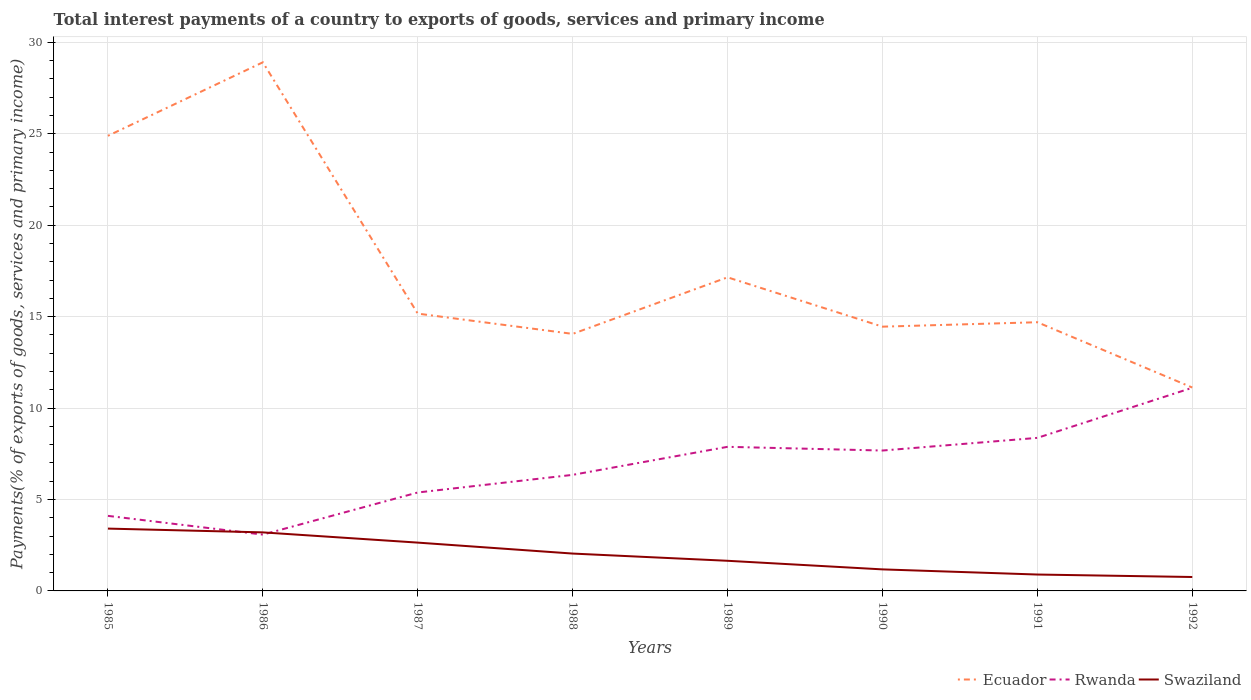Across all years, what is the maximum total interest payments in Swaziland?
Your response must be concise. 0.76. In which year was the total interest payments in Swaziland maximum?
Give a very brief answer. 1992. What is the total total interest payments in Swaziland in the graph?
Provide a succinct answer. 0.56. What is the difference between the highest and the second highest total interest payments in Rwanda?
Ensure brevity in your answer.  8.03. Is the total interest payments in Rwanda strictly greater than the total interest payments in Ecuador over the years?
Ensure brevity in your answer.  Yes. How many lines are there?
Provide a succinct answer. 3. How many years are there in the graph?
Your response must be concise. 8. Are the values on the major ticks of Y-axis written in scientific E-notation?
Make the answer very short. No. Does the graph contain any zero values?
Your answer should be compact. No. Does the graph contain grids?
Provide a short and direct response. Yes. Where does the legend appear in the graph?
Keep it short and to the point. Bottom right. How are the legend labels stacked?
Offer a very short reply. Horizontal. What is the title of the graph?
Give a very brief answer. Total interest payments of a country to exports of goods, services and primary income. Does "Hungary" appear as one of the legend labels in the graph?
Give a very brief answer. No. What is the label or title of the X-axis?
Provide a short and direct response. Years. What is the label or title of the Y-axis?
Offer a very short reply. Payments(% of exports of goods, services and primary income). What is the Payments(% of exports of goods, services and primary income) in Ecuador in 1985?
Provide a short and direct response. 24.89. What is the Payments(% of exports of goods, services and primary income) in Rwanda in 1985?
Your response must be concise. 4.11. What is the Payments(% of exports of goods, services and primary income) of Swaziland in 1985?
Your answer should be very brief. 3.41. What is the Payments(% of exports of goods, services and primary income) in Ecuador in 1986?
Your answer should be compact. 28.91. What is the Payments(% of exports of goods, services and primary income) of Rwanda in 1986?
Offer a very short reply. 3.08. What is the Payments(% of exports of goods, services and primary income) in Swaziland in 1986?
Make the answer very short. 3.2. What is the Payments(% of exports of goods, services and primary income) of Ecuador in 1987?
Your answer should be very brief. 15.17. What is the Payments(% of exports of goods, services and primary income) of Rwanda in 1987?
Ensure brevity in your answer.  5.38. What is the Payments(% of exports of goods, services and primary income) in Swaziland in 1987?
Give a very brief answer. 2.64. What is the Payments(% of exports of goods, services and primary income) of Ecuador in 1988?
Give a very brief answer. 14.06. What is the Payments(% of exports of goods, services and primary income) in Rwanda in 1988?
Offer a very short reply. 6.35. What is the Payments(% of exports of goods, services and primary income) in Swaziland in 1988?
Your response must be concise. 2.04. What is the Payments(% of exports of goods, services and primary income) of Ecuador in 1989?
Your answer should be very brief. 17.15. What is the Payments(% of exports of goods, services and primary income) in Rwanda in 1989?
Offer a very short reply. 7.88. What is the Payments(% of exports of goods, services and primary income) of Swaziland in 1989?
Provide a succinct answer. 1.65. What is the Payments(% of exports of goods, services and primary income) of Ecuador in 1990?
Your answer should be compact. 14.45. What is the Payments(% of exports of goods, services and primary income) of Rwanda in 1990?
Provide a short and direct response. 7.68. What is the Payments(% of exports of goods, services and primary income) in Swaziland in 1990?
Offer a terse response. 1.18. What is the Payments(% of exports of goods, services and primary income) of Ecuador in 1991?
Ensure brevity in your answer.  14.69. What is the Payments(% of exports of goods, services and primary income) in Rwanda in 1991?
Ensure brevity in your answer.  8.37. What is the Payments(% of exports of goods, services and primary income) of Swaziland in 1991?
Offer a very short reply. 0.9. What is the Payments(% of exports of goods, services and primary income) in Ecuador in 1992?
Give a very brief answer. 11.12. What is the Payments(% of exports of goods, services and primary income) of Rwanda in 1992?
Your answer should be very brief. 11.11. What is the Payments(% of exports of goods, services and primary income) of Swaziland in 1992?
Give a very brief answer. 0.76. Across all years, what is the maximum Payments(% of exports of goods, services and primary income) in Ecuador?
Make the answer very short. 28.91. Across all years, what is the maximum Payments(% of exports of goods, services and primary income) in Rwanda?
Give a very brief answer. 11.11. Across all years, what is the maximum Payments(% of exports of goods, services and primary income) in Swaziland?
Your answer should be very brief. 3.41. Across all years, what is the minimum Payments(% of exports of goods, services and primary income) of Ecuador?
Your answer should be compact. 11.12. Across all years, what is the minimum Payments(% of exports of goods, services and primary income) of Rwanda?
Your response must be concise. 3.08. Across all years, what is the minimum Payments(% of exports of goods, services and primary income) in Swaziland?
Make the answer very short. 0.76. What is the total Payments(% of exports of goods, services and primary income) in Ecuador in the graph?
Provide a short and direct response. 140.44. What is the total Payments(% of exports of goods, services and primary income) of Rwanda in the graph?
Offer a very short reply. 53.96. What is the total Payments(% of exports of goods, services and primary income) of Swaziland in the graph?
Offer a very short reply. 15.78. What is the difference between the Payments(% of exports of goods, services and primary income) in Ecuador in 1985 and that in 1986?
Make the answer very short. -4.02. What is the difference between the Payments(% of exports of goods, services and primary income) of Rwanda in 1985 and that in 1986?
Your response must be concise. 1.02. What is the difference between the Payments(% of exports of goods, services and primary income) in Swaziland in 1985 and that in 1986?
Provide a succinct answer. 0.21. What is the difference between the Payments(% of exports of goods, services and primary income) in Ecuador in 1985 and that in 1987?
Provide a short and direct response. 9.72. What is the difference between the Payments(% of exports of goods, services and primary income) of Rwanda in 1985 and that in 1987?
Your response must be concise. -1.28. What is the difference between the Payments(% of exports of goods, services and primary income) in Swaziland in 1985 and that in 1987?
Provide a short and direct response. 0.77. What is the difference between the Payments(% of exports of goods, services and primary income) of Ecuador in 1985 and that in 1988?
Give a very brief answer. 10.83. What is the difference between the Payments(% of exports of goods, services and primary income) in Rwanda in 1985 and that in 1988?
Offer a very short reply. -2.24. What is the difference between the Payments(% of exports of goods, services and primary income) in Swaziland in 1985 and that in 1988?
Make the answer very short. 1.37. What is the difference between the Payments(% of exports of goods, services and primary income) in Ecuador in 1985 and that in 1989?
Ensure brevity in your answer.  7.74. What is the difference between the Payments(% of exports of goods, services and primary income) in Rwanda in 1985 and that in 1989?
Provide a short and direct response. -3.78. What is the difference between the Payments(% of exports of goods, services and primary income) in Swaziland in 1985 and that in 1989?
Your answer should be very brief. 1.76. What is the difference between the Payments(% of exports of goods, services and primary income) of Ecuador in 1985 and that in 1990?
Ensure brevity in your answer.  10.44. What is the difference between the Payments(% of exports of goods, services and primary income) of Rwanda in 1985 and that in 1990?
Keep it short and to the point. -3.57. What is the difference between the Payments(% of exports of goods, services and primary income) in Swaziland in 1985 and that in 1990?
Ensure brevity in your answer.  2.23. What is the difference between the Payments(% of exports of goods, services and primary income) in Ecuador in 1985 and that in 1991?
Your response must be concise. 10.19. What is the difference between the Payments(% of exports of goods, services and primary income) of Rwanda in 1985 and that in 1991?
Offer a terse response. -4.27. What is the difference between the Payments(% of exports of goods, services and primary income) in Swaziland in 1985 and that in 1991?
Your answer should be very brief. 2.51. What is the difference between the Payments(% of exports of goods, services and primary income) in Ecuador in 1985 and that in 1992?
Make the answer very short. 13.77. What is the difference between the Payments(% of exports of goods, services and primary income) of Rwanda in 1985 and that in 1992?
Offer a very short reply. -7.01. What is the difference between the Payments(% of exports of goods, services and primary income) of Swaziland in 1985 and that in 1992?
Provide a short and direct response. 2.65. What is the difference between the Payments(% of exports of goods, services and primary income) of Ecuador in 1986 and that in 1987?
Give a very brief answer. 13.74. What is the difference between the Payments(% of exports of goods, services and primary income) of Rwanda in 1986 and that in 1987?
Your response must be concise. -2.3. What is the difference between the Payments(% of exports of goods, services and primary income) of Swaziland in 1986 and that in 1987?
Make the answer very short. 0.56. What is the difference between the Payments(% of exports of goods, services and primary income) in Ecuador in 1986 and that in 1988?
Make the answer very short. 14.85. What is the difference between the Payments(% of exports of goods, services and primary income) in Rwanda in 1986 and that in 1988?
Provide a short and direct response. -3.27. What is the difference between the Payments(% of exports of goods, services and primary income) of Swaziland in 1986 and that in 1988?
Ensure brevity in your answer.  1.16. What is the difference between the Payments(% of exports of goods, services and primary income) of Ecuador in 1986 and that in 1989?
Give a very brief answer. 11.76. What is the difference between the Payments(% of exports of goods, services and primary income) in Rwanda in 1986 and that in 1989?
Make the answer very short. -4.8. What is the difference between the Payments(% of exports of goods, services and primary income) in Swaziland in 1986 and that in 1989?
Keep it short and to the point. 1.55. What is the difference between the Payments(% of exports of goods, services and primary income) in Ecuador in 1986 and that in 1990?
Offer a terse response. 14.46. What is the difference between the Payments(% of exports of goods, services and primary income) of Rwanda in 1986 and that in 1990?
Offer a very short reply. -4.6. What is the difference between the Payments(% of exports of goods, services and primary income) in Swaziland in 1986 and that in 1990?
Your answer should be compact. 2.02. What is the difference between the Payments(% of exports of goods, services and primary income) of Ecuador in 1986 and that in 1991?
Offer a very short reply. 14.22. What is the difference between the Payments(% of exports of goods, services and primary income) in Rwanda in 1986 and that in 1991?
Your answer should be very brief. -5.29. What is the difference between the Payments(% of exports of goods, services and primary income) of Swaziland in 1986 and that in 1991?
Offer a terse response. 2.31. What is the difference between the Payments(% of exports of goods, services and primary income) in Ecuador in 1986 and that in 1992?
Offer a very short reply. 17.79. What is the difference between the Payments(% of exports of goods, services and primary income) of Rwanda in 1986 and that in 1992?
Offer a terse response. -8.03. What is the difference between the Payments(% of exports of goods, services and primary income) of Swaziland in 1986 and that in 1992?
Make the answer very short. 2.44. What is the difference between the Payments(% of exports of goods, services and primary income) of Ecuador in 1987 and that in 1988?
Provide a short and direct response. 1.11. What is the difference between the Payments(% of exports of goods, services and primary income) of Rwanda in 1987 and that in 1988?
Offer a terse response. -0.96. What is the difference between the Payments(% of exports of goods, services and primary income) in Swaziland in 1987 and that in 1988?
Offer a terse response. 0.6. What is the difference between the Payments(% of exports of goods, services and primary income) in Ecuador in 1987 and that in 1989?
Provide a succinct answer. -1.98. What is the difference between the Payments(% of exports of goods, services and primary income) of Rwanda in 1987 and that in 1989?
Make the answer very short. -2.5. What is the difference between the Payments(% of exports of goods, services and primary income) of Swaziland in 1987 and that in 1989?
Provide a succinct answer. 0.99. What is the difference between the Payments(% of exports of goods, services and primary income) of Ecuador in 1987 and that in 1990?
Provide a succinct answer. 0.71. What is the difference between the Payments(% of exports of goods, services and primary income) in Rwanda in 1987 and that in 1990?
Your answer should be compact. -2.29. What is the difference between the Payments(% of exports of goods, services and primary income) of Swaziland in 1987 and that in 1990?
Your response must be concise. 1.46. What is the difference between the Payments(% of exports of goods, services and primary income) of Ecuador in 1987 and that in 1991?
Ensure brevity in your answer.  0.47. What is the difference between the Payments(% of exports of goods, services and primary income) in Rwanda in 1987 and that in 1991?
Your answer should be compact. -2.99. What is the difference between the Payments(% of exports of goods, services and primary income) in Swaziland in 1987 and that in 1991?
Offer a very short reply. 1.75. What is the difference between the Payments(% of exports of goods, services and primary income) of Ecuador in 1987 and that in 1992?
Give a very brief answer. 4.04. What is the difference between the Payments(% of exports of goods, services and primary income) of Rwanda in 1987 and that in 1992?
Keep it short and to the point. -5.73. What is the difference between the Payments(% of exports of goods, services and primary income) of Swaziland in 1987 and that in 1992?
Give a very brief answer. 1.88. What is the difference between the Payments(% of exports of goods, services and primary income) in Ecuador in 1988 and that in 1989?
Your response must be concise. -3.09. What is the difference between the Payments(% of exports of goods, services and primary income) in Rwanda in 1988 and that in 1989?
Keep it short and to the point. -1.53. What is the difference between the Payments(% of exports of goods, services and primary income) of Swaziland in 1988 and that in 1989?
Offer a very short reply. 0.4. What is the difference between the Payments(% of exports of goods, services and primary income) in Ecuador in 1988 and that in 1990?
Ensure brevity in your answer.  -0.39. What is the difference between the Payments(% of exports of goods, services and primary income) in Rwanda in 1988 and that in 1990?
Give a very brief answer. -1.33. What is the difference between the Payments(% of exports of goods, services and primary income) of Swaziland in 1988 and that in 1990?
Offer a very short reply. 0.87. What is the difference between the Payments(% of exports of goods, services and primary income) in Ecuador in 1988 and that in 1991?
Offer a very short reply. -0.64. What is the difference between the Payments(% of exports of goods, services and primary income) of Rwanda in 1988 and that in 1991?
Your answer should be compact. -2.02. What is the difference between the Payments(% of exports of goods, services and primary income) of Swaziland in 1988 and that in 1991?
Ensure brevity in your answer.  1.15. What is the difference between the Payments(% of exports of goods, services and primary income) in Ecuador in 1988 and that in 1992?
Make the answer very short. 2.93. What is the difference between the Payments(% of exports of goods, services and primary income) in Rwanda in 1988 and that in 1992?
Offer a terse response. -4.76. What is the difference between the Payments(% of exports of goods, services and primary income) in Swaziland in 1988 and that in 1992?
Your answer should be compact. 1.28. What is the difference between the Payments(% of exports of goods, services and primary income) of Ecuador in 1989 and that in 1990?
Make the answer very short. 2.7. What is the difference between the Payments(% of exports of goods, services and primary income) of Rwanda in 1989 and that in 1990?
Offer a terse response. 0.2. What is the difference between the Payments(% of exports of goods, services and primary income) of Swaziland in 1989 and that in 1990?
Your answer should be compact. 0.47. What is the difference between the Payments(% of exports of goods, services and primary income) in Ecuador in 1989 and that in 1991?
Offer a very short reply. 2.46. What is the difference between the Payments(% of exports of goods, services and primary income) in Rwanda in 1989 and that in 1991?
Make the answer very short. -0.49. What is the difference between the Payments(% of exports of goods, services and primary income) in Swaziland in 1989 and that in 1991?
Provide a short and direct response. 0.75. What is the difference between the Payments(% of exports of goods, services and primary income) of Ecuador in 1989 and that in 1992?
Keep it short and to the point. 6.03. What is the difference between the Payments(% of exports of goods, services and primary income) of Rwanda in 1989 and that in 1992?
Give a very brief answer. -3.23. What is the difference between the Payments(% of exports of goods, services and primary income) in Swaziland in 1989 and that in 1992?
Your answer should be compact. 0.89. What is the difference between the Payments(% of exports of goods, services and primary income) in Ecuador in 1990 and that in 1991?
Your answer should be compact. -0.24. What is the difference between the Payments(% of exports of goods, services and primary income) of Rwanda in 1990 and that in 1991?
Provide a short and direct response. -0.69. What is the difference between the Payments(% of exports of goods, services and primary income) of Swaziland in 1990 and that in 1991?
Ensure brevity in your answer.  0.28. What is the difference between the Payments(% of exports of goods, services and primary income) in Ecuador in 1990 and that in 1992?
Offer a terse response. 3.33. What is the difference between the Payments(% of exports of goods, services and primary income) in Rwanda in 1990 and that in 1992?
Keep it short and to the point. -3.43. What is the difference between the Payments(% of exports of goods, services and primary income) in Swaziland in 1990 and that in 1992?
Make the answer very short. 0.42. What is the difference between the Payments(% of exports of goods, services and primary income) of Ecuador in 1991 and that in 1992?
Your answer should be very brief. 3.57. What is the difference between the Payments(% of exports of goods, services and primary income) in Rwanda in 1991 and that in 1992?
Your answer should be very brief. -2.74. What is the difference between the Payments(% of exports of goods, services and primary income) in Swaziland in 1991 and that in 1992?
Your answer should be very brief. 0.13. What is the difference between the Payments(% of exports of goods, services and primary income) in Ecuador in 1985 and the Payments(% of exports of goods, services and primary income) in Rwanda in 1986?
Offer a very short reply. 21.81. What is the difference between the Payments(% of exports of goods, services and primary income) in Ecuador in 1985 and the Payments(% of exports of goods, services and primary income) in Swaziland in 1986?
Provide a short and direct response. 21.69. What is the difference between the Payments(% of exports of goods, services and primary income) in Rwanda in 1985 and the Payments(% of exports of goods, services and primary income) in Swaziland in 1986?
Provide a short and direct response. 0.9. What is the difference between the Payments(% of exports of goods, services and primary income) in Ecuador in 1985 and the Payments(% of exports of goods, services and primary income) in Rwanda in 1987?
Provide a succinct answer. 19.51. What is the difference between the Payments(% of exports of goods, services and primary income) in Ecuador in 1985 and the Payments(% of exports of goods, services and primary income) in Swaziland in 1987?
Make the answer very short. 22.25. What is the difference between the Payments(% of exports of goods, services and primary income) of Rwanda in 1985 and the Payments(% of exports of goods, services and primary income) of Swaziland in 1987?
Offer a very short reply. 1.46. What is the difference between the Payments(% of exports of goods, services and primary income) of Ecuador in 1985 and the Payments(% of exports of goods, services and primary income) of Rwanda in 1988?
Offer a terse response. 18.54. What is the difference between the Payments(% of exports of goods, services and primary income) in Ecuador in 1985 and the Payments(% of exports of goods, services and primary income) in Swaziland in 1988?
Offer a terse response. 22.85. What is the difference between the Payments(% of exports of goods, services and primary income) in Rwanda in 1985 and the Payments(% of exports of goods, services and primary income) in Swaziland in 1988?
Ensure brevity in your answer.  2.06. What is the difference between the Payments(% of exports of goods, services and primary income) in Ecuador in 1985 and the Payments(% of exports of goods, services and primary income) in Rwanda in 1989?
Provide a succinct answer. 17.01. What is the difference between the Payments(% of exports of goods, services and primary income) of Ecuador in 1985 and the Payments(% of exports of goods, services and primary income) of Swaziland in 1989?
Keep it short and to the point. 23.24. What is the difference between the Payments(% of exports of goods, services and primary income) of Rwanda in 1985 and the Payments(% of exports of goods, services and primary income) of Swaziland in 1989?
Keep it short and to the point. 2.46. What is the difference between the Payments(% of exports of goods, services and primary income) in Ecuador in 1985 and the Payments(% of exports of goods, services and primary income) in Rwanda in 1990?
Ensure brevity in your answer.  17.21. What is the difference between the Payments(% of exports of goods, services and primary income) of Ecuador in 1985 and the Payments(% of exports of goods, services and primary income) of Swaziland in 1990?
Provide a succinct answer. 23.71. What is the difference between the Payments(% of exports of goods, services and primary income) in Rwanda in 1985 and the Payments(% of exports of goods, services and primary income) in Swaziland in 1990?
Your answer should be very brief. 2.93. What is the difference between the Payments(% of exports of goods, services and primary income) in Ecuador in 1985 and the Payments(% of exports of goods, services and primary income) in Rwanda in 1991?
Provide a succinct answer. 16.52. What is the difference between the Payments(% of exports of goods, services and primary income) of Ecuador in 1985 and the Payments(% of exports of goods, services and primary income) of Swaziland in 1991?
Offer a very short reply. 23.99. What is the difference between the Payments(% of exports of goods, services and primary income) of Rwanda in 1985 and the Payments(% of exports of goods, services and primary income) of Swaziland in 1991?
Offer a very short reply. 3.21. What is the difference between the Payments(% of exports of goods, services and primary income) in Ecuador in 1985 and the Payments(% of exports of goods, services and primary income) in Rwanda in 1992?
Your answer should be very brief. 13.78. What is the difference between the Payments(% of exports of goods, services and primary income) of Ecuador in 1985 and the Payments(% of exports of goods, services and primary income) of Swaziland in 1992?
Offer a very short reply. 24.13. What is the difference between the Payments(% of exports of goods, services and primary income) of Rwanda in 1985 and the Payments(% of exports of goods, services and primary income) of Swaziland in 1992?
Give a very brief answer. 3.34. What is the difference between the Payments(% of exports of goods, services and primary income) in Ecuador in 1986 and the Payments(% of exports of goods, services and primary income) in Rwanda in 1987?
Provide a succinct answer. 23.53. What is the difference between the Payments(% of exports of goods, services and primary income) in Ecuador in 1986 and the Payments(% of exports of goods, services and primary income) in Swaziland in 1987?
Make the answer very short. 26.27. What is the difference between the Payments(% of exports of goods, services and primary income) of Rwanda in 1986 and the Payments(% of exports of goods, services and primary income) of Swaziland in 1987?
Keep it short and to the point. 0.44. What is the difference between the Payments(% of exports of goods, services and primary income) in Ecuador in 1986 and the Payments(% of exports of goods, services and primary income) in Rwanda in 1988?
Provide a succinct answer. 22.56. What is the difference between the Payments(% of exports of goods, services and primary income) of Ecuador in 1986 and the Payments(% of exports of goods, services and primary income) of Swaziland in 1988?
Provide a short and direct response. 26.87. What is the difference between the Payments(% of exports of goods, services and primary income) in Rwanda in 1986 and the Payments(% of exports of goods, services and primary income) in Swaziland in 1988?
Ensure brevity in your answer.  1.04. What is the difference between the Payments(% of exports of goods, services and primary income) of Ecuador in 1986 and the Payments(% of exports of goods, services and primary income) of Rwanda in 1989?
Give a very brief answer. 21.03. What is the difference between the Payments(% of exports of goods, services and primary income) of Ecuador in 1986 and the Payments(% of exports of goods, services and primary income) of Swaziland in 1989?
Provide a succinct answer. 27.26. What is the difference between the Payments(% of exports of goods, services and primary income) in Rwanda in 1986 and the Payments(% of exports of goods, services and primary income) in Swaziland in 1989?
Offer a very short reply. 1.43. What is the difference between the Payments(% of exports of goods, services and primary income) in Ecuador in 1986 and the Payments(% of exports of goods, services and primary income) in Rwanda in 1990?
Your answer should be very brief. 21.23. What is the difference between the Payments(% of exports of goods, services and primary income) in Ecuador in 1986 and the Payments(% of exports of goods, services and primary income) in Swaziland in 1990?
Make the answer very short. 27.73. What is the difference between the Payments(% of exports of goods, services and primary income) of Rwanda in 1986 and the Payments(% of exports of goods, services and primary income) of Swaziland in 1990?
Offer a very short reply. 1.9. What is the difference between the Payments(% of exports of goods, services and primary income) of Ecuador in 1986 and the Payments(% of exports of goods, services and primary income) of Rwanda in 1991?
Ensure brevity in your answer.  20.54. What is the difference between the Payments(% of exports of goods, services and primary income) of Ecuador in 1986 and the Payments(% of exports of goods, services and primary income) of Swaziland in 1991?
Offer a very short reply. 28.01. What is the difference between the Payments(% of exports of goods, services and primary income) in Rwanda in 1986 and the Payments(% of exports of goods, services and primary income) in Swaziland in 1991?
Your answer should be very brief. 2.18. What is the difference between the Payments(% of exports of goods, services and primary income) of Ecuador in 1986 and the Payments(% of exports of goods, services and primary income) of Rwanda in 1992?
Offer a very short reply. 17.8. What is the difference between the Payments(% of exports of goods, services and primary income) in Ecuador in 1986 and the Payments(% of exports of goods, services and primary income) in Swaziland in 1992?
Keep it short and to the point. 28.15. What is the difference between the Payments(% of exports of goods, services and primary income) in Rwanda in 1986 and the Payments(% of exports of goods, services and primary income) in Swaziland in 1992?
Provide a short and direct response. 2.32. What is the difference between the Payments(% of exports of goods, services and primary income) of Ecuador in 1987 and the Payments(% of exports of goods, services and primary income) of Rwanda in 1988?
Offer a terse response. 8.82. What is the difference between the Payments(% of exports of goods, services and primary income) of Ecuador in 1987 and the Payments(% of exports of goods, services and primary income) of Swaziland in 1988?
Offer a terse response. 13.12. What is the difference between the Payments(% of exports of goods, services and primary income) of Rwanda in 1987 and the Payments(% of exports of goods, services and primary income) of Swaziland in 1988?
Provide a succinct answer. 3.34. What is the difference between the Payments(% of exports of goods, services and primary income) in Ecuador in 1987 and the Payments(% of exports of goods, services and primary income) in Rwanda in 1989?
Ensure brevity in your answer.  7.29. What is the difference between the Payments(% of exports of goods, services and primary income) of Ecuador in 1987 and the Payments(% of exports of goods, services and primary income) of Swaziland in 1989?
Provide a succinct answer. 13.52. What is the difference between the Payments(% of exports of goods, services and primary income) in Rwanda in 1987 and the Payments(% of exports of goods, services and primary income) in Swaziland in 1989?
Your answer should be compact. 3.74. What is the difference between the Payments(% of exports of goods, services and primary income) in Ecuador in 1987 and the Payments(% of exports of goods, services and primary income) in Rwanda in 1990?
Your response must be concise. 7.49. What is the difference between the Payments(% of exports of goods, services and primary income) in Ecuador in 1987 and the Payments(% of exports of goods, services and primary income) in Swaziland in 1990?
Provide a succinct answer. 13.99. What is the difference between the Payments(% of exports of goods, services and primary income) in Rwanda in 1987 and the Payments(% of exports of goods, services and primary income) in Swaziland in 1990?
Make the answer very short. 4.21. What is the difference between the Payments(% of exports of goods, services and primary income) of Ecuador in 1987 and the Payments(% of exports of goods, services and primary income) of Rwanda in 1991?
Your answer should be compact. 6.8. What is the difference between the Payments(% of exports of goods, services and primary income) of Ecuador in 1987 and the Payments(% of exports of goods, services and primary income) of Swaziland in 1991?
Your answer should be very brief. 14.27. What is the difference between the Payments(% of exports of goods, services and primary income) of Rwanda in 1987 and the Payments(% of exports of goods, services and primary income) of Swaziland in 1991?
Your response must be concise. 4.49. What is the difference between the Payments(% of exports of goods, services and primary income) of Ecuador in 1987 and the Payments(% of exports of goods, services and primary income) of Rwanda in 1992?
Your answer should be very brief. 4.06. What is the difference between the Payments(% of exports of goods, services and primary income) of Ecuador in 1987 and the Payments(% of exports of goods, services and primary income) of Swaziland in 1992?
Offer a terse response. 14.4. What is the difference between the Payments(% of exports of goods, services and primary income) of Rwanda in 1987 and the Payments(% of exports of goods, services and primary income) of Swaziland in 1992?
Keep it short and to the point. 4.62. What is the difference between the Payments(% of exports of goods, services and primary income) of Ecuador in 1988 and the Payments(% of exports of goods, services and primary income) of Rwanda in 1989?
Your response must be concise. 6.18. What is the difference between the Payments(% of exports of goods, services and primary income) in Ecuador in 1988 and the Payments(% of exports of goods, services and primary income) in Swaziland in 1989?
Make the answer very short. 12.41. What is the difference between the Payments(% of exports of goods, services and primary income) of Rwanda in 1988 and the Payments(% of exports of goods, services and primary income) of Swaziland in 1989?
Your response must be concise. 4.7. What is the difference between the Payments(% of exports of goods, services and primary income) of Ecuador in 1988 and the Payments(% of exports of goods, services and primary income) of Rwanda in 1990?
Ensure brevity in your answer.  6.38. What is the difference between the Payments(% of exports of goods, services and primary income) of Ecuador in 1988 and the Payments(% of exports of goods, services and primary income) of Swaziland in 1990?
Your answer should be compact. 12.88. What is the difference between the Payments(% of exports of goods, services and primary income) in Rwanda in 1988 and the Payments(% of exports of goods, services and primary income) in Swaziland in 1990?
Make the answer very short. 5.17. What is the difference between the Payments(% of exports of goods, services and primary income) of Ecuador in 1988 and the Payments(% of exports of goods, services and primary income) of Rwanda in 1991?
Your response must be concise. 5.69. What is the difference between the Payments(% of exports of goods, services and primary income) in Ecuador in 1988 and the Payments(% of exports of goods, services and primary income) in Swaziland in 1991?
Offer a very short reply. 13.16. What is the difference between the Payments(% of exports of goods, services and primary income) in Rwanda in 1988 and the Payments(% of exports of goods, services and primary income) in Swaziland in 1991?
Your response must be concise. 5.45. What is the difference between the Payments(% of exports of goods, services and primary income) of Ecuador in 1988 and the Payments(% of exports of goods, services and primary income) of Rwanda in 1992?
Keep it short and to the point. 2.95. What is the difference between the Payments(% of exports of goods, services and primary income) in Ecuador in 1988 and the Payments(% of exports of goods, services and primary income) in Swaziland in 1992?
Provide a short and direct response. 13.3. What is the difference between the Payments(% of exports of goods, services and primary income) in Rwanda in 1988 and the Payments(% of exports of goods, services and primary income) in Swaziland in 1992?
Offer a very short reply. 5.59. What is the difference between the Payments(% of exports of goods, services and primary income) of Ecuador in 1989 and the Payments(% of exports of goods, services and primary income) of Rwanda in 1990?
Your answer should be very brief. 9.47. What is the difference between the Payments(% of exports of goods, services and primary income) of Ecuador in 1989 and the Payments(% of exports of goods, services and primary income) of Swaziland in 1990?
Your answer should be very brief. 15.97. What is the difference between the Payments(% of exports of goods, services and primary income) of Rwanda in 1989 and the Payments(% of exports of goods, services and primary income) of Swaziland in 1990?
Offer a terse response. 6.7. What is the difference between the Payments(% of exports of goods, services and primary income) in Ecuador in 1989 and the Payments(% of exports of goods, services and primary income) in Rwanda in 1991?
Keep it short and to the point. 8.78. What is the difference between the Payments(% of exports of goods, services and primary income) in Ecuador in 1989 and the Payments(% of exports of goods, services and primary income) in Swaziland in 1991?
Your answer should be very brief. 16.25. What is the difference between the Payments(% of exports of goods, services and primary income) of Rwanda in 1989 and the Payments(% of exports of goods, services and primary income) of Swaziland in 1991?
Offer a very short reply. 6.98. What is the difference between the Payments(% of exports of goods, services and primary income) in Ecuador in 1989 and the Payments(% of exports of goods, services and primary income) in Rwanda in 1992?
Your answer should be compact. 6.04. What is the difference between the Payments(% of exports of goods, services and primary income) of Ecuador in 1989 and the Payments(% of exports of goods, services and primary income) of Swaziland in 1992?
Provide a succinct answer. 16.39. What is the difference between the Payments(% of exports of goods, services and primary income) in Rwanda in 1989 and the Payments(% of exports of goods, services and primary income) in Swaziland in 1992?
Provide a short and direct response. 7.12. What is the difference between the Payments(% of exports of goods, services and primary income) of Ecuador in 1990 and the Payments(% of exports of goods, services and primary income) of Rwanda in 1991?
Your response must be concise. 6.08. What is the difference between the Payments(% of exports of goods, services and primary income) in Ecuador in 1990 and the Payments(% of exports of goods, services and primary income) in Swaziland in 1991?
Your answer should be very brief. 13.56. What is the difference between the Payments(% of exports of goods, services and primary income) of Rwanda in 1990 and the Payments(% of exports of goods, services and primary income) of Swaziland in 1991?
Offer a very short reply. 6.78. What is the difference between the Payments(% of exports of goods, services and primary income) of Ecuador in 1990 and the Payments(% of exports of goods, services and primary income) of Rwanda in 1992?
Provide a short and direct response. 3.34. What is the difference between the Payments(% of exports of goods, services and primary income) in Ecuador in 1990 and the Payments(% of exports of goods, services and primary income) in Swaziland in 1992?
Provide a short and direct response. 13.69. What is the difference between the Payments(% of exports of goods, services and primary income) in Rwanda in 1990 and the Payments(% of exports of goods, services and primary income) in Swaziland in 1992?
Provide a short and direct response. 6.92. What is the difference between the Payments(% of exports of goods, services and primary income) of Ecuador in 1991 and the Payments(% of exports of goods, services and primary income) of Rwanda in 1992?
Provide a succinct answer. 3.58. What is the difference between the Payments(% of exports of goods, services and primary income) of Ecuador in 1991 and the Payments(% of exports of goods, services and primary income) of Swaziland in 1992?
Make the answer very short. 13.93. What is the difference between the Payments(% of exports of goods, services and primary income) of Rwanda in 1991 and the Payments(% of exports of goods, services and primary income) of Swaziland in 1992?
Offer a very short reply. 7.61. What is the average Payments(% of exports of goods, services and primary income) in Ecuador per year?
Provide a short and direct response. 17.56. What is the average Payments(% of exports of goods, services and primary income) of Rwanda per year?
Offer a terse response. 6.74. What is the average Payments(% of exports of goods, services and primary income) of Swaziland per year?
Offer a terse response. 1.97. In the year 1985, what is the difference between the Payments(% of exports of goods, services and primary income) in Ecuador and Payments(% of exports of goods, services and primary income) in Rwanda?
Offer a terse response. 20.78. In the year 1985, what is the difference between the Payments(% of exports of goods, services and primary income) in Ecuador and Payments(% of exports of goods, services and primary income) in Swaziland?
Keep it short and to the point. 21.48. In the year 1985, what is the difference between the Payments(% of exports of goods, services and primary income) of Rwanda and Payments(% of exports of goods, services and primary income) of Swaziland?
Ensure brevity in your answer.  0.7. In the year 1986, what is the difference between the Payments(% of exports of goods, services and primary income) of Ecuador and Payments(% of exports of goods, services and primary income) of Rwanda?
Provide a short and direct response. 25.83. In the year 1986, what is the difference between the Payments(% of exports of goods, services and primary income) in Ecuador and Payments(% of exports of goods, services and primary income) in Swaziland?
Offer a very short reply. 25.71. In the year 1986, what is the difference between the Payments(% of exports of goods, services and primary income) of Rwanda and Payments(% of exports of goods, services and primary income) of Swaziland?
Give a very brief answer. -0.12. In the year 1987, what is the difference between the Payments(% of exports of goods, services and primary income) in Ecuador and Payments(% of exports of goods, services and primary income) in Rwanda?
Offer a terse response. 9.78. In the year 1987, what is the difference between the Payments(% of exports of goods, services and primary income) in Ecuador and Payments(% of exports of goods, services and primary income) in Swaziland?
Make the answer very short. 12.52. In the year 1987, what is the difference between the Payments(% of exports of goods, services and primary income) in Rwanda and Payments(% of exports of goods, services and primary income) in Swaziland?
Your answer should be very brief. 2.74. In the year 1988, what is the difference between the Payments(% of exports of goods, services and primary income) of Ecuador and Payments(% of exports of goods, services and primary income) of Rwanda?
Give a very brief answer. 7.71. In the year 1988, what is the difference between the Payments(% of exports of goods, services and primary income) of Ecuador and Payments(% of exports of goods, services and primary income) of Swaziland?
Your answer should be very brief. 12.01. In the year 1988, what is the difference between the Payments(% of exports of goods, services and primary income) of Rwanda and Payments(% of exports of goods, services and primary income) of Swaziland?
Make the answer very short. 4.3. In the year 1989, what is the difference between the Payments(% of exports of goods, services and primary income) of Ecuador and Payments(% of exports of goods, services and primary income) of Rwanda?
Offer a very short reply. 9.27. In the year 1989, what is the difference between the Payments(% of exports of goods, services and primary income) in Ecuador and Payments(% of exports of goods, services and primary income) in Swaziland?
Provide a short and direct response. 15.5. In the year 1989, what is the difference between the Payments(% of exports of goods, services and primary income) of Rwanda and Payments(% of exports of goods, services and primary income) of Swaziland?
Your response must be concise. 6.23. In the year 1990, what is the difference between the Payments(% of exports of goods, services and primary income) of Ecuador and Payments(% of exports of goods, services and primary income) of Rwanda?
Make the answer very short. 6.77. In the year 1990, what is the difference between the Payments(% of exports of goods, services and primary income) of Ecuador and Payments(% of exports of goods, services and primary income) of Swaziland?
Provide a succinct answer. 13.27. In the year 1990, what is the difference between the Payments(% of exports of goods, services and primary income) in Rwanda and Payments(% of exports of goods, services and primary income) in Swaziland?
Keep it short and to the point. 6.5. In the year 1991, what is the difference between the Payments(% of exports of goods, services and primary income) in Ecuador and Payments(% of exports of goods, services and primary income) in Rwanda?
Your answer should be very brief. 6.32. In the year 1991, what is the difference between the Payments(% of exports of goods, services and primary income) in Ecuador and Payments(% of exports of goods, services and primary income) in Swaziland?
Give a very brief answer. 13.8. In the year 1991, what is the difference between the Payments(% of exports of goods, services and primary income) in Rwanda and Payments(% of exports of goods, services and primary income) in Swaziland?
Keep it short and to the point. 7.47. In the year 1992, what is the difference between the Payments(% of exports of goods, services and primary income) of Ecuador and Payments(% of exports of goods, services and primary income) of Rwanda?
Ensure brevity in your answer.  0.01. In the year 1992, what is the difference between the Payments(% of exports of goods, services and primary income) of Ecuador and Payments(% of exports of goods, services and primary income) of Swaziland?
Ensure brevity in your answer.  10.36. In the year 1992, what is the difference between the Payments(% of exports of goods, services and primary income) of Rwanda and Payments(% of exports of goods, services and primary income) of Swaziland?
Your answer should be very brief. 10.35. What is the ratio of the Payments(% of exports of goods, services and primary income) of Ecuador in 1985 to that in 1986?
Provide a short and direct response. 0.86. What is the ratio of the Payments(% of exports of goods, services and primary income) of Rwanda in 1985 to that in 1986?
Your response must be concise. 1.33. What is the ratio of the Payments(% of exports of goods, services and primary income) of Swaziland in 1985 to that in 1986?
Keep it short and to the point. 1.06. What is the ratio of the Payments(% of exports of goods, services and primary income) of Ecuador in 1985 to that in 1987?
Make the answer very short. 1.64. What is the ratio of the Payments(% of exports of goods, services and primary income) in Rwanda in 1985 to that in 1987?
Provide a succinct answer. 0.76. What is the ratio of the Payments(% of exports of goods, services and primary income) in Swaziland in 1985 to that in 1987?
Ensure brevity in your answer.  1.29. What is the ratio of the Payments(% of exports of goods, services and primary income) in Ecuador in 1985 to that in 1988?
Offer a very short reply. 1.77. What is the ratio of the Payments(% of exports of goods, services and primary income) in Rwanda in 1985 to that in 1988?
Your response must be concise. 0.65. What is the ratio of the Payments(% of exports of goods, services and primary income) in Swaziland in 1985 to that in 1988?
Offer a very short reply. 1.67. What is the ratio of the Payments(% of exports of goods, services and primary income) in Ecuador in 1985 to that in 1989?
Your answer should be very brief. 1.45. What is the ratio of the Payments(% of exports of goods, services and primary income) of Rwanda in 1985 to that in 1989?
Keep it short and to the point. 0.52. What is the ratio of the Payments(% of exports of goods, services and primary income) in Swaziland in 1985 to that in 1989?
Your response must be concise. 2.07. What is the ratio of the Payments(% of exports of goods, services and primary income) in Ecuador in 1985 to that in 1990?
Your answer should be compact. 1.72. What is the ratio of the Payments(% of exports of goods, services and primary income) in Rwanda in 1985 to that in 1990?
Ensure brevity in your answer.  0.53. What is the ratio of the Payments(% of exports of goods, services and primary income) in Swaziland in 1985 to that in 1990?
Ensure brevity in your answer.  2.89. What is the ratio of the Payments(% of exports of goods, services and primary income) in Ecuador in 1985 to that in 1991?
Give a very brief answer. 1.69. What is the ratio of the Payments(% of exports of goods, services and primary income) of Rwanda in 1985 to that in 1991?
Provide a short and direct response. 0.49. What is the ratio of the Payments(% of exports of goods, services and primary income) in Swaziland in 1985 to that in 1991?
Your answer should be very brief. 3.8. What is the ratio of the Payments(% of exports of goods, services and primary income) in Ecuador in 1985 to that in 1992?
Ensure brevity in your answer.  2.24. What is the ratio of the Payments(% of exports of goods, services and primary income) of Rwanda in 1985 to that in 1992?
Provide a succinct answer. 0.37. What is the ratio of the Payments(% of exports of goods, services and primary income) in Swaziland in 1985 to that in 1992?
Keep it short and to the point. 4.48. What is the ratio of the Payments(% of exports of goods, services and primary income) of Ecuador in 1986 to that in 1987?
Give a very brief answer. 1.91. What is the ratio of the Payments(% of exports of goods, services and primary income) in Rwanda in 1986 to that in 1987?
Offer a very short reply. 0.57. What is the ratio of the Payments(% of exports of goods, services and primary income) of Swaziland in 1986 to that in 1987?
Offer a very short reply. 1.21. What is the ratio of the Payments(% of exports of goods, services and primary income) of Ecuador in 1986 to that in 1988?
Give a very brief answer. 2.06. What is the ratio of the Payments(% of exports of goods, services and primary income) of Rwanda in 1986 to that in 1988?
Offer a very short reply. 0.49. What is the ratio of the Payments(% of exports of goods, services and primary income) of Swaziland in 1986 to that in 1988?
Give a very brief answer. 1.57. What is the ratio of the Payments(% of exports of goods, services and primary income) of Ecuador in 1986 to that in 1989?
Keep it short and to the point. 1.69. What is the ratio of the Payments(% of exports of goods, services and primary income) in Rwanda in 1986 to that in 1989?
Your answer should be very brief. 0.39. What is the ratio of the Payments(% of exports of goods, services and primary income) of Swaziland in 1986 to that in 1989?
Your response must be concise. 1.94. What is the ratio of the Payments(% of exports of goods, services and primary income) in Ecuador in 1986 to that in 1990?
Your answer should be very brief. 2. What is the ratio of the Payments(% of exports of goods, services and primary income) of Rwanda in 1986 to that in 1990?
Ensure brevity in your answer.  0.4. What is the ratio of the Payments(% of exports of goods, services and primary income) in Swaziland in 1986 to that in 1990?
Ensure brevity in your answer.  2.72. What is the ratio of the Payments(% of exports of goods, services and primary income) in Ecuador in 1986 to that in 1991?
Give a very brief answer. 1.97. What is the ratio of the Payments(% of exports of goods, services and primary income) of Rwanda in 1986 to that in 1991?
Make the answer very short. 0.37. What is the ratio of the Payments(% of exports of goods, services and primary income) in Swaziland in 1986 to that in 1991?
Offer a very short reply. 3.57. What is the ratio of the Payments(% of exports of goods, services and primary income) in Ecuador in 1986 to that in 1992?
Your response must be concise. 2.6. What is the ratio of the Payments(% of exports of goods, services and primary income) in Rwanda in 1986 to that in 1992?
Make the answer very short. 0.28. What is the ratio of the Payments(% of exports of goods, services and primary income) in Swaziland in 1986 to that in 1992?
Provide a short and direct response. 4.2. What is the ratio of the Payments(% of exports of goods, services and primary income) of Ecuador in 1987 to that in 1988?
Give a very brief answer. 1.08. What is the ratio of the Payments(% of exports of goods, services and primary income) in Rwanda in 1987 to that in 1988?
Ensure brevity in your answer.  0.85. What is the ratio of the Payments(% of exports of goods, services and primary income) of Swaziland in 1987 to that in 1988?
Ensure brevity in your answer.  1.29. What is the ratio of the Payments(% of exports of goods, services and primary income) of Ecuador in 1987 to that in 1989?
Your answer should be very brief. 0.88. What is the ratio of the Payments(% of exports of goods, services and primary income) in Rwanda in 1987 to that in 1989?
Provide a short and direct response. 0.68. What is the ratio of the Payments(% of exports of goods, services and primary income) of Swaziland in 1987 to that in 1989?
Ensure brevity in your answer.  1.6. What is the ratio of the Payments(% of exports of goods, services and primary income) in Ecuador in 1987 to that in 1990?
Offer a very short reply. 1.05. What is the ratio of the Payments(% of exports of goods, services and primary income) in Rwanda in 1987 to that in 1990?
Offer a terse response. 0.7. What is the ratio of the Payments(% of exports of goods, services and primary income) in Swaziland in 1987 to that in 1990?
Give a very brief answer. 2.24. What is the ratio of the Payments(% of exports of goods, services and primary income) in Ecuador in 1987 to that in 1991?
Provide a succinct answer. 1.03. What is the ratio of the Payments(% of exports of goods, services and primary income) in Rwanda in 1987 to that in 1991?
Offer a terse response. 0.64. What is the ratio of the Payments(% of exports of goods, services and primary income) of Swaziland in 1987 to that in 1991?
Give a very brief answer. 2.95. What is the ratio of the Payments(% of exports of goods, services and primary income) of Ecuador in 1987 to that in 1992?
Your response must be concise. 1.36. What is the ratio of the Payments(% of exports of goods, services and primary income) of Rwanda in 1987 to that in 1992?
Provide a short and direct response. 0.48. What is the ratio of the Payments(% of exports of goods, services and primary income) in Swaziland in 1987 to that in 1992?
Keep it short and to the point. 3.47. What is the ratio of the Payments(% of exports of goods, services and primary income) of Ecuador in 1988 to that in 1989?
Give a very brief answer. 0.82. What is the ratio of the Payments(% of exports of goods, services and primary income) in Rwanda in 1988 to that in 1989?
Give a very brief answer. 0.81. What is the ratio of the Payments(% of exports of goods, services and primary income) of Swaziland in 1988 to that in 1989?
Offer a terse response. 1.24. What is the ratio of the Payments(% of exports of goods, services and primary income) in Ecuador in 1988 to that in 1990?
Provide a short and direct response. 0.97. What is the ratio of the Payments(% of exports of goods, services and primary income) in Rwanda in 1988 to that in 1990?
Ensure brevity in your answer.  0.83. What is the ratio of the Payments(% of exports of goods, services and primary income) in Swaziland in 1988 to that in 1990?
Give a very brief answer. 1.73. What is the ratio of the Payments(% of exports of goods, services and primary income) in Ecuador in 1988 to that in 1991?
Offer a very short reply. 0.96. What is the ratio of the Payments(% of exports of goods, services and primary income) of Rwanda in 1988 to that in 1991?
Your response must be concise. 0.76. What is the ratio of the Payments(% of exports of goods, services and primary income) of Swaziland in 1988 to that in 1991?
Offer a very short reply. 2.28. What is the ratio of the Payments(% of exports of goods, services and primary income) of Ecuador in 1988 to that in 1992?
Offer a terse response. 1.26. What is the ratio of the Payments(% of exports of goods, services and primary income) in Rwanda in 1988 to that in 1992?
Offer a very short reply. 0.57. What is the ratio of the Payments(% of exports of goods, services and primary income) of Swaziland in 1988 to that in 1992?
Keep it short and to the point. 2.68. What is the ratio of the Payments(% of exports of goods, services and primary income) of Ecuador in 1989 to that in 1990?
Your answer should be very brief. 1.19. What is the ratio of the Payments(% of exports of goods, services and primary income) in Rwanda in 1989 to that in 1990?
Offer a very short reply. 1.03. What is the ratio of the Payments(% of exports of goods, services and primary income) of Swaziland in 1989 to that in 1990?
Keep it short and to the point. 1.4. What is the ratio of the Payments(% of exports of goods, services and primary income) of Ecuador in 1989 to that in 1991?
Provide a succinct answer. 1.17. What is the ratio of the Payments(% of exports of goods, services and primary income) of Rwanda in 1989 to that in 1991?
Ensure brevity in your answer.  0.94. What is the ratio of the Payments(% of exports of goods, services and primary income) of Swaziland in 1989 to that in 1991?
Provide a short and direct response. 1.84. What is the ratio of the Payments(% of exports of goods, services and primary income) in Ecuador in 1989 to that in 1992?
Provide a succinct answer. 1.54. What is the ratio of the Payments(% of exports of goods, services and primary income) in Rwanda in 1989 to that in 1992?
Provide a short and direct response. 0.71. What is the ratio of the Payments(% of exports of goods, services and primary income) in Swaziland in 1989 to that in 1992?
Keep it short and to the point. 2.16. What is the ratio of the Payments(% of exports of goods, services and primary income) of Ecuador in 1990 to that in 1991?
Make the answer very short. 0.98. What is the ratio of the Payments(% of exports of goods, services and primary income) of Rwanda in 1990 to that in 1991?
Provide a succinct answer. 0.92. What is the ratio of the Payments(% of exports of goods, services and primary income) of Swaziland in 1990 to that in 1991?
Provide a succinct answer. 1.31. What is the ratio of the Payments(% of exports of goods, services and primary income) of Ecuador in 1990 to that in 1992?
Provide a short and direct response. 1.3. What is the ratio of the Payments(% of exports of goods, services and primary income) in Rwanda in 1990 to that in 1992?
Your response must be concise. 0.69. What is the ratio of the Payments(% of exports of goods, services and primary income) in Swaziland in 1990 to that in 1992?
Provide a short and direct response. 1.55. What is the ratio of the Payments(% of exports of goods, services and primary income) in Ecuador in 1991 to that in 1992?
Keep it short and to the point. 1.32. What is the ratio of the Payments(% of exports of goods, services and primary income) of Rwanda in 1991 to that in 1992?
Make the answer very short. 0.75. What is the ratio of the Payments(% of exports of goods, services and primary income) in Swaziland in 1991 to that in 1992?
Keep it short and to the point. 1.18. What is the difference between the highest and the second highest Payments(% of exports of goods, services and primary income) of Ecuador?
Provide a succinct answer. 4.02. What is the difference between the highest and the second highest Payments(% of exports of goods, services and primary income) of Rwanda?
Provide a short and direct response. 2.74. What is the difference between the highest and the second highest Payments(% of exports of goods, services and primary income) in Swaziland?
Your answer should be compact. 0.21. What is the difference between the highest and the lowest Payments(% of exports of goods, services and primary income) of Ecuador?
Provide a short and direct response. 17.79. What is the difference between the highest and the lowest Payments(% of exports of goods, services and primary income) of Rwanda?
Give a very brief answer. 8.03. What is the difference between the highest and the lowest Payments(% of exports of goods, services and primary income) in Swaziland?
Offer a very short reply. 2.65. 